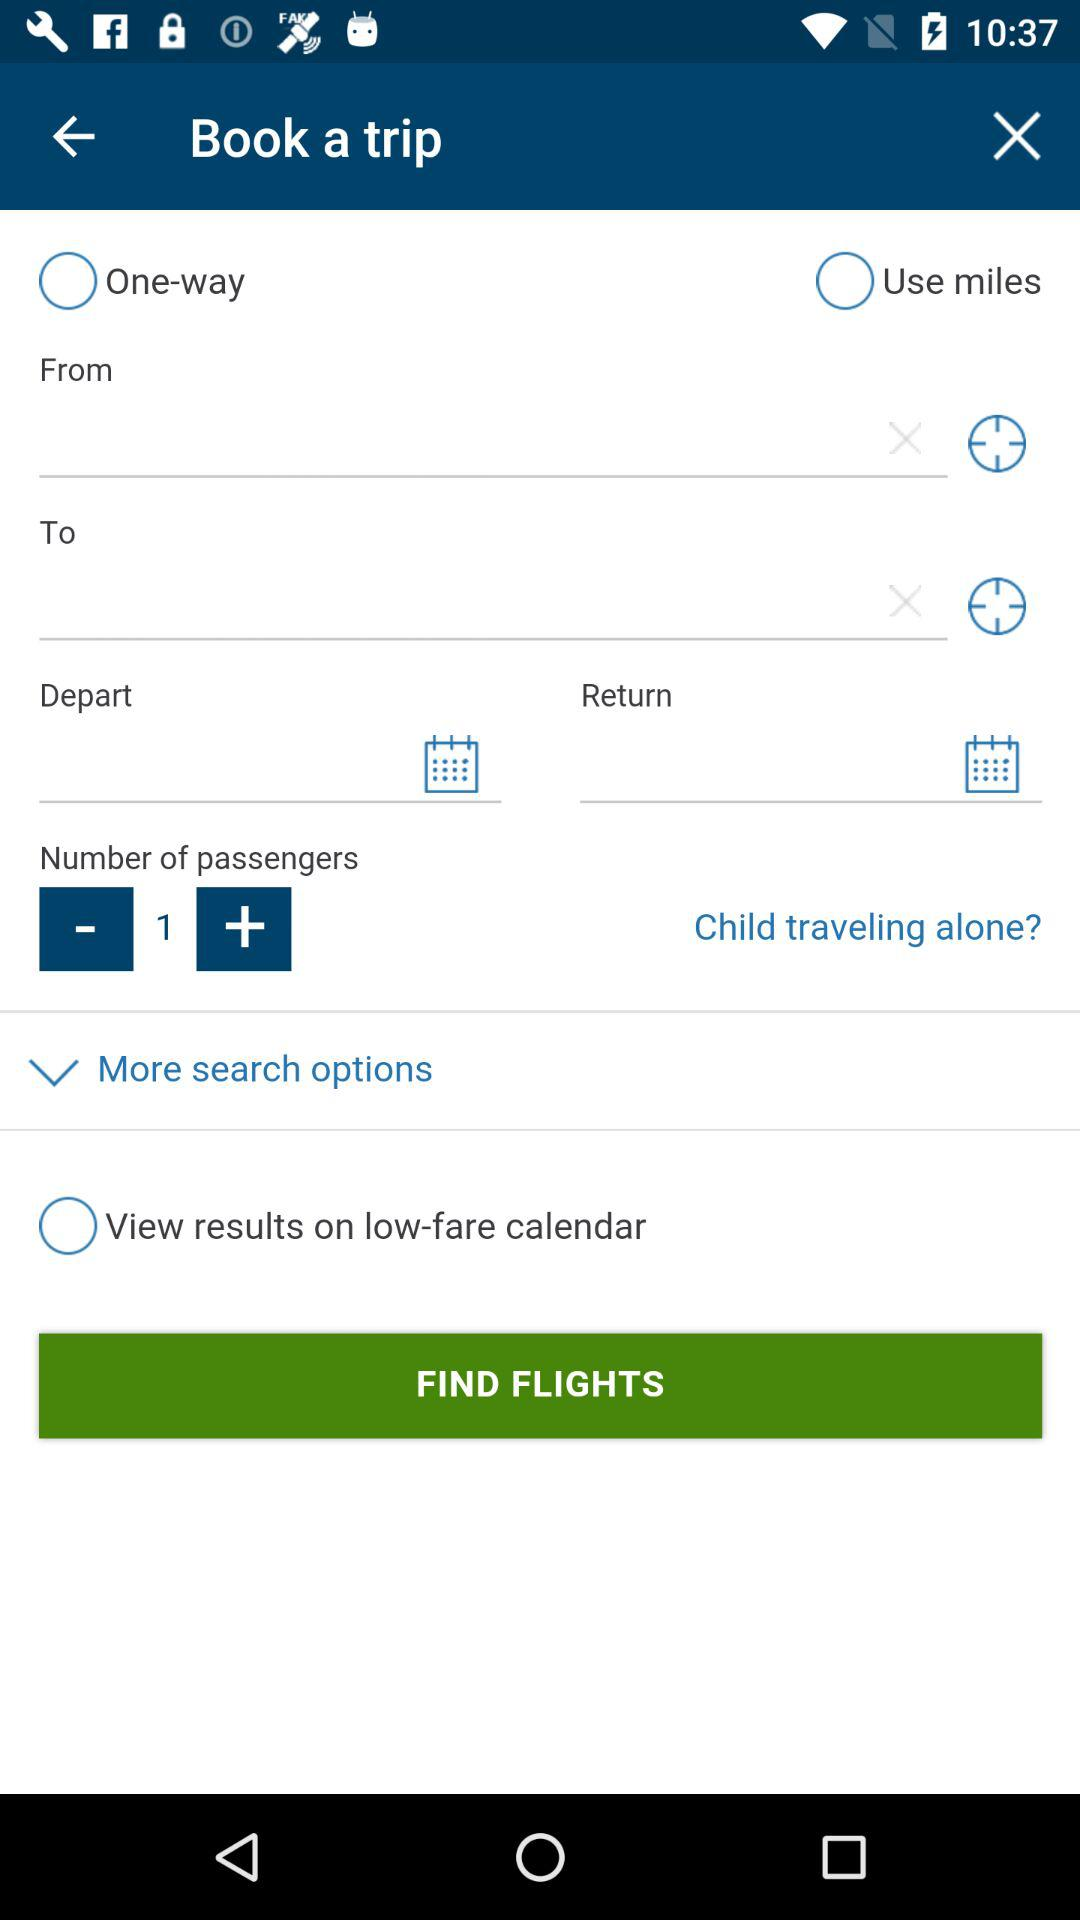What is the number of selected passengers? The number of selected passengers is 1. 